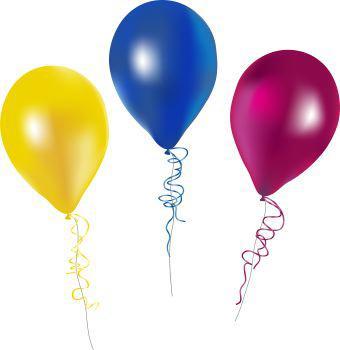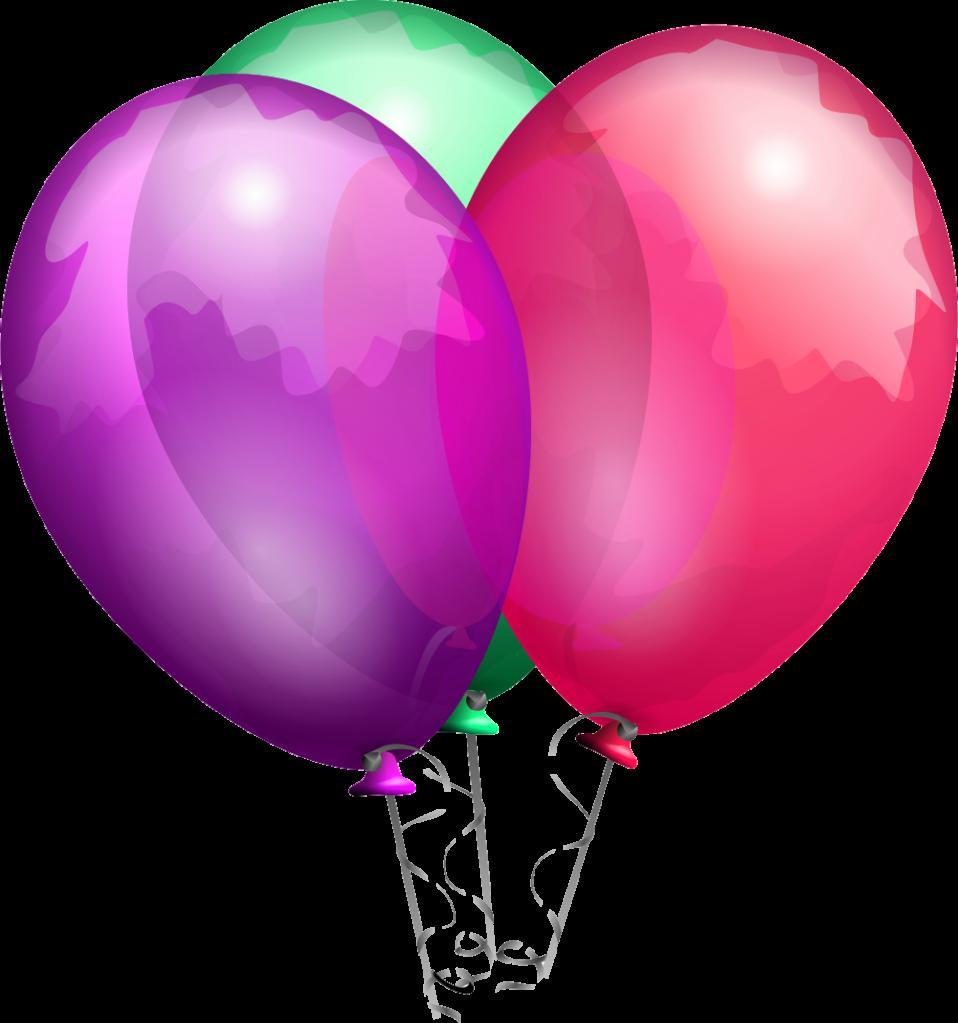The first image is the image on the left, the second image is the image on the right. Given the left and right images, does the statement "In one image, there is one blue balloon, one yellow balloon, and one purple balloon side by side" hold true? Answer yes or no. Yes. The first image is the image on the left, the second image is the image on the right. Analyze the images presented: Is the assertion "An image shows exactly three overlapping balloons, and one of the balloons is yellow." valid? Answer yes or no. No. 